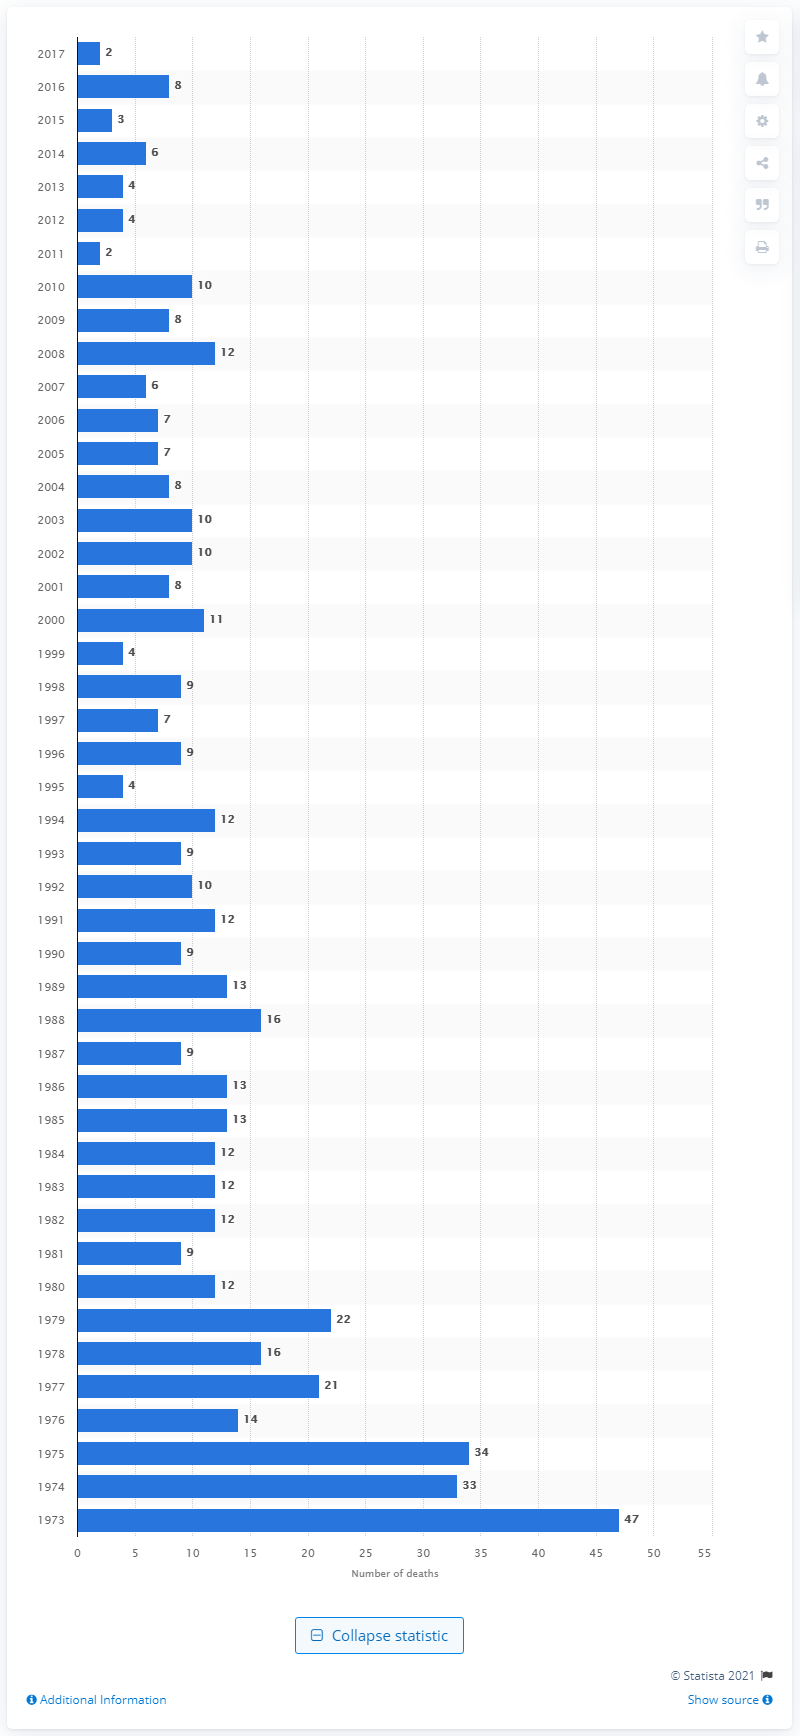Mention a couple of crucial points in this snapshot. In 1973, there were approximately 2 abortion-related deaths in the United States. In 1973, approximately 47 deaths were related to abortions. 